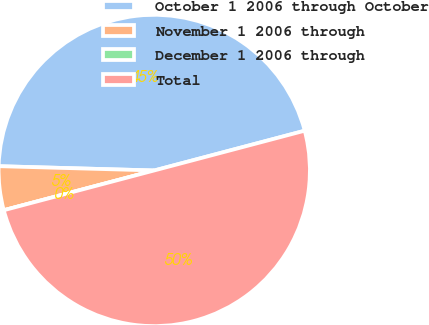Convert chart to OTSL. <chart><loc_0><loc_0><loc_500><loc_500><pie_chart><fcel>October 1 2006 through October<fcel>November 1 2006 through<fcel>December 1 2006 through<fcel>Total<nl><fcel>45.45%<fcel>4.55%<fcel>0.0%<fcel>50.0%<nl></chart> 